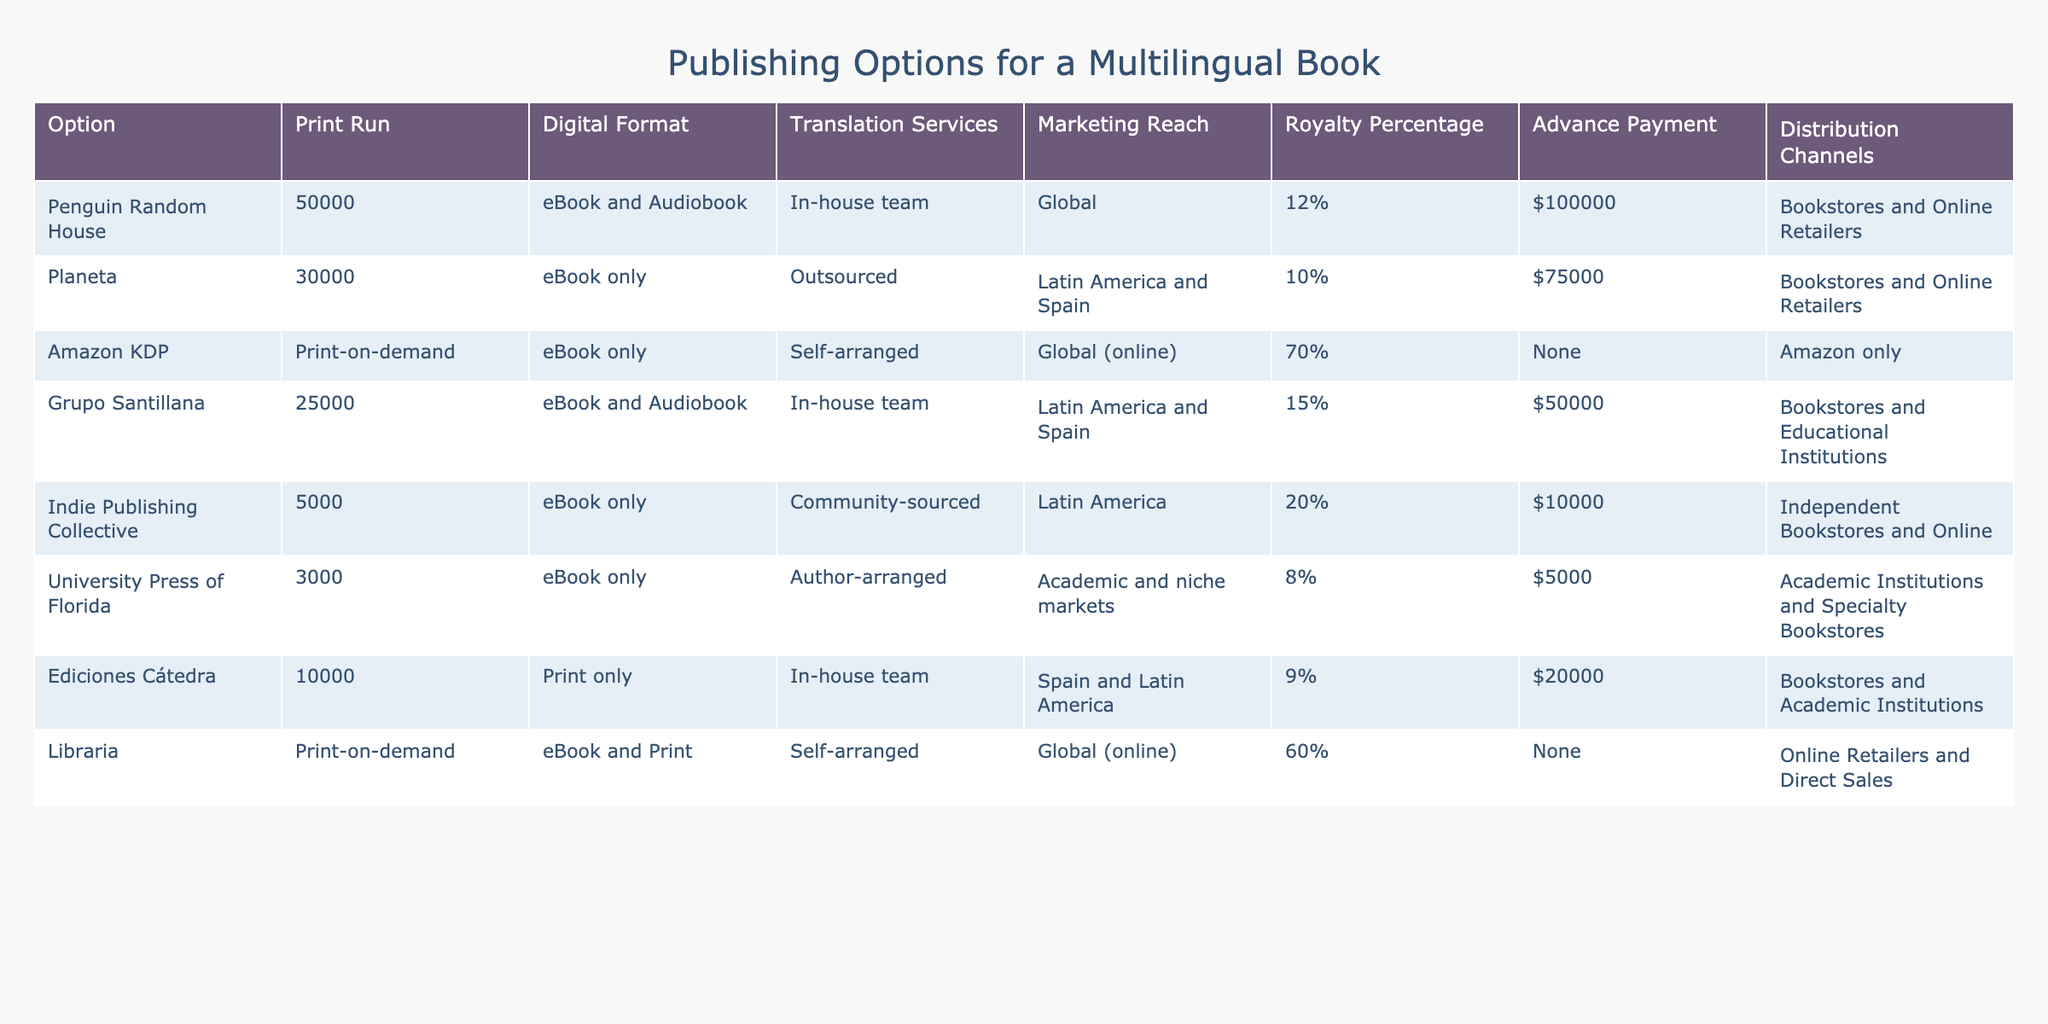What is the highest royalty percentage offered by a publisher in the table? The royalty percentages listed are 12%, 10%, 70%, 15%, 20%, 8%, 9%, and 60%. The highest is 70% provided by Amazon KDP.
Answer: 70% How many copies does the Print Run for Grupo Santillana have? The Print Run for Grupo Santillana is listed as 25,000 copies.
Answer: 25000 Which publisher has the largest advance payment? The advance payments listed are $100,000, $75,000, None, $50,000, $10,000, $5,000, $20,000, and None. The largest advance payment is $100,000 from Penguin Random House.
Answer: $100000 Are there any publishers in the table that offer both eBook and Audiobook formats? The only publishers that offer both formats are Penguin Random House and Grupo Santillana. Therefore, the answer is yes, there are publishers that offer both formats.
Answer: Yes What is the average Print Run of the publishers listed? The Print Runs are 50,000, 30,000, 5,000, 25,000, 3,000, 10,000, and 30,000. This sums up to 153,000 copies and dividing by 7 gives an average of 21,857.14, rounded to 21,857.
Answer: 21857 Which publisher has the smallest distribution reach? The distribution reach for each publisher varies, and the smallest is University Press of Florida, focused on Academic and niche markets.
Answer: University Press of Florida Which publisher has chosen to use outsourced translation services? Out of the publishers listed, Planeta is the one that uses outsourced translation services for their books.
Answer: Planeta What is the total number of copies produced by all publishers combined? Summing the Print Runs gives: 50,000 + 30,000 + 5,000 + 25,000 + 3,000 + 10,000 + 10000 + 30000 = 1,18,000.
Answer: 118000 Which publisher has the least marketing reach? The least marketing reach is associated with University Press of Florida, which targets academic and niche markets.
Answer: University Press of Florida 